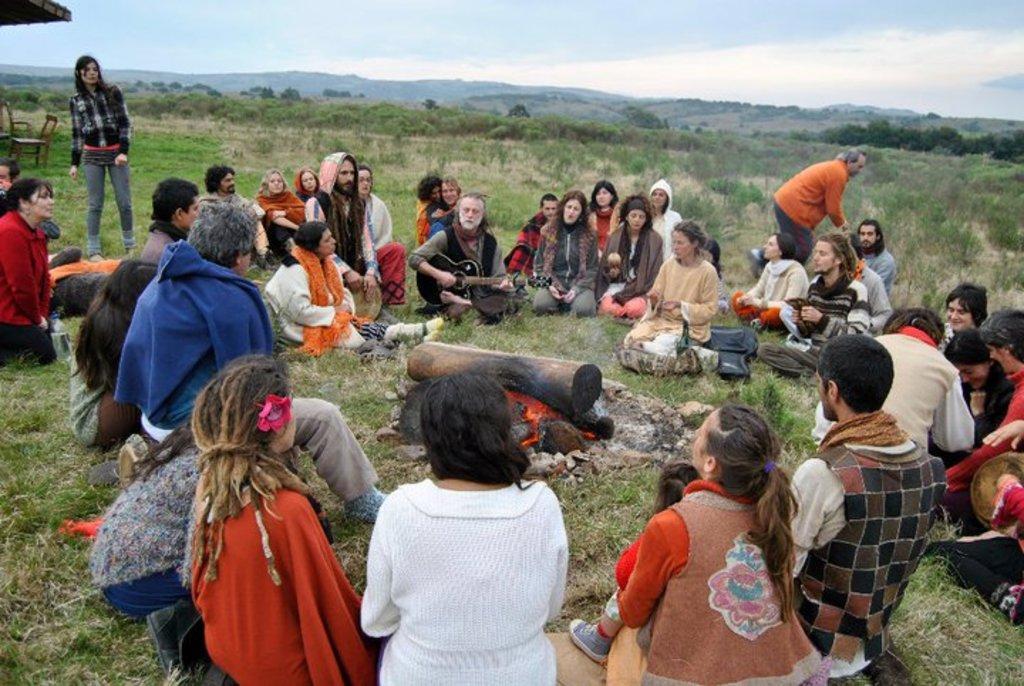In one or two sentences, can you explain what this image depicts? In this image there are group of persons standing and sitting. In the center there is a firewood and in the background there is grass on the ground and there are trees and on the left side there are empty chairs, there are mountains in the background and the sky is cloudy. 